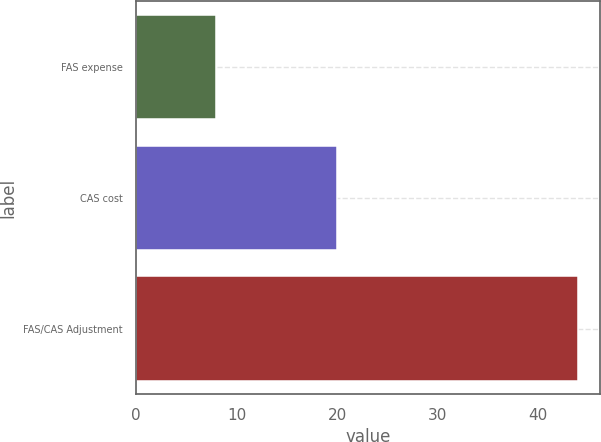Convert chart to OTSL. <chart><loc_0><loc_0><loc_500><loc_500><bar_chart><fcel>FAS expense<fcel>CAS cost<fcel>FAS/CAS Adjustment<nl><fcel>8<fcel>20<fcel>44<nl></chart> 